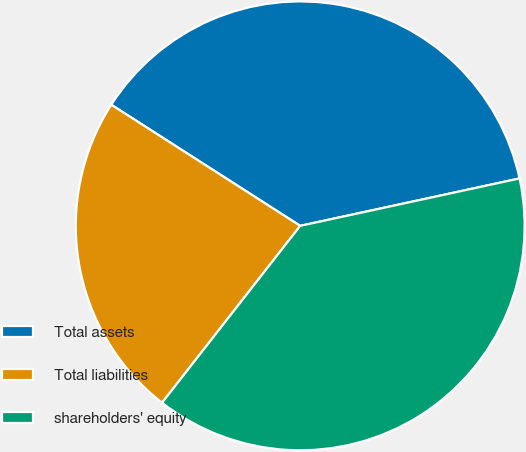Convert chart to OTSL. <chart><loc_0><loc_0><loc_500><loc_500><pie_chart><fcel>Total assets<fcel>Total liabilities<fcel>shareholders' equity<nl><fcel>37.54%<fcel>23.52%<fcel>38.94%<nl></chart> 